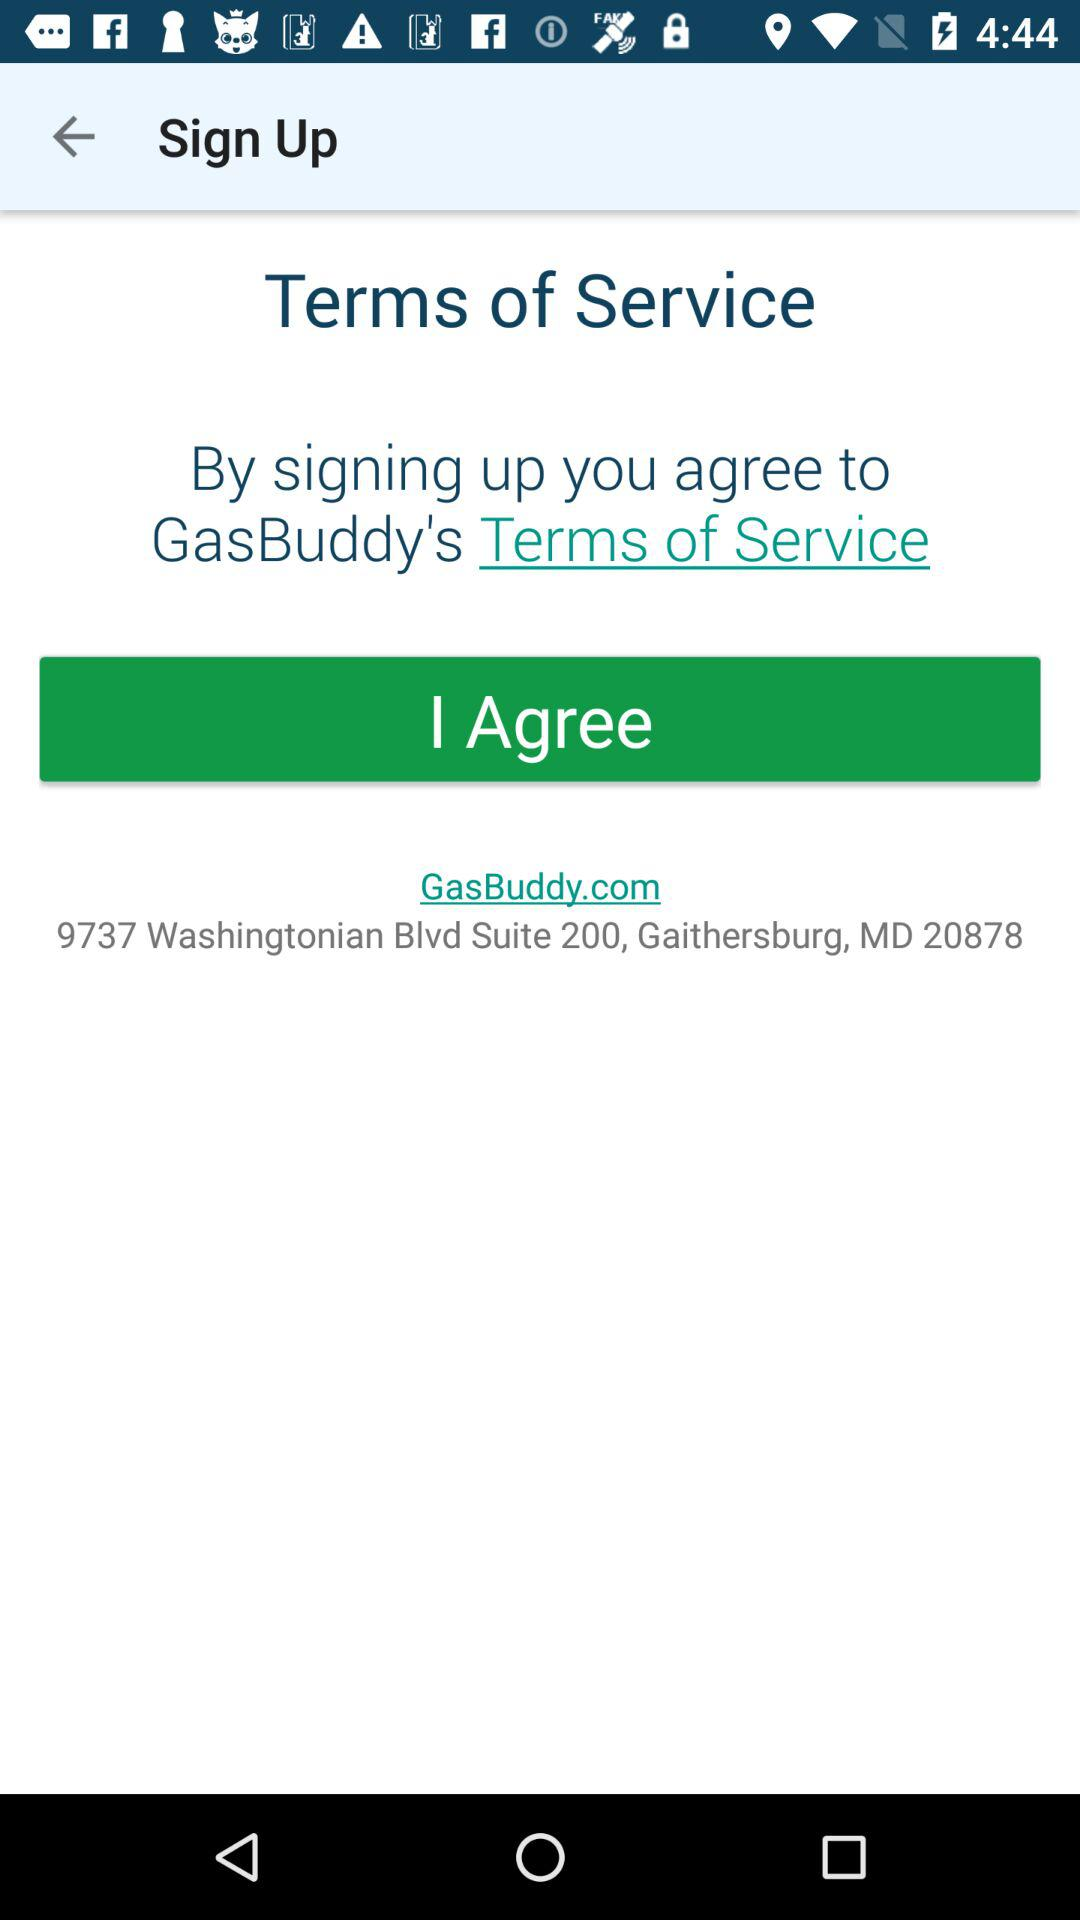What application is asking for a sign-up? The application asking for a sign-up is "GasBuddy". 